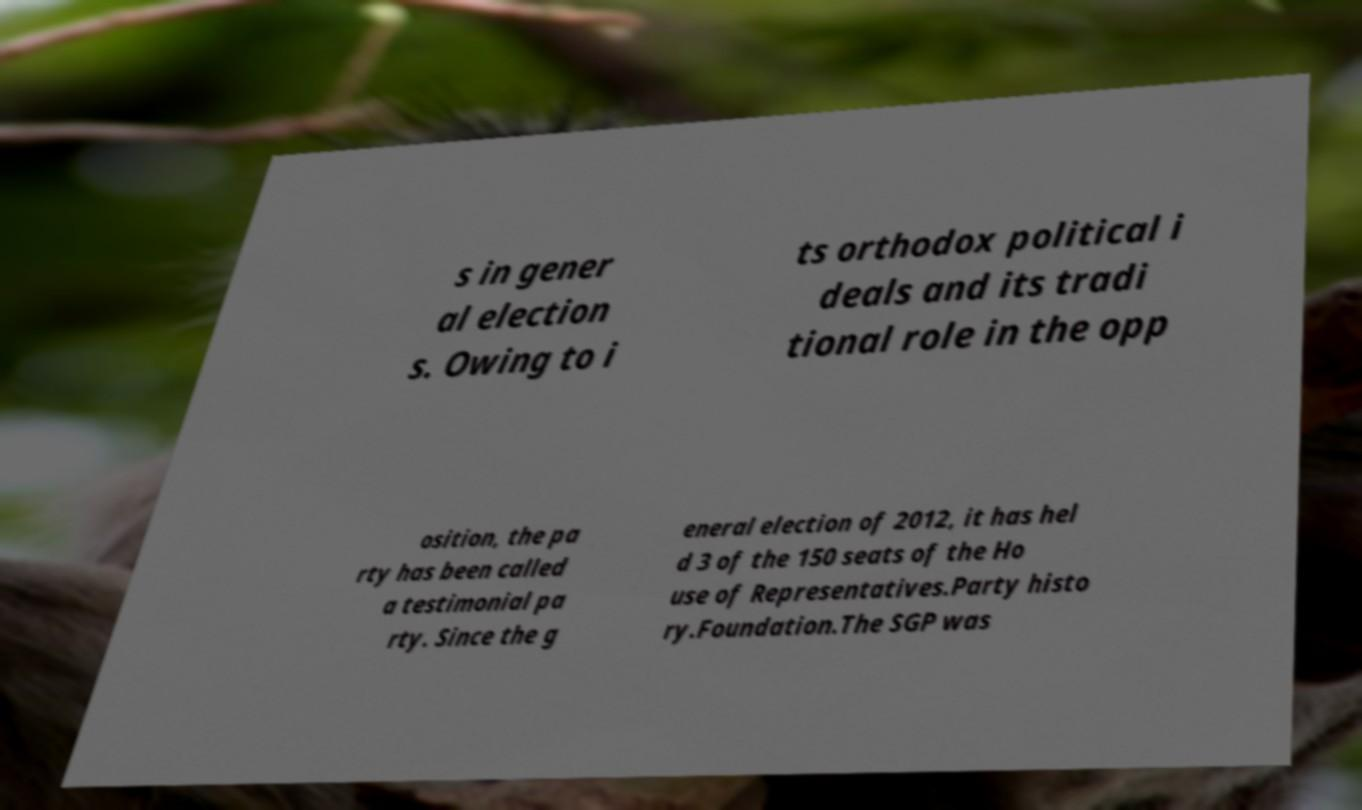Could you extract and type out the text from this image? s in gener al election s. Owing to i ts orthodox political i deals and its tradi tional role in the opp osition, the pa rty has been called a testimonial pa rty. Since the g eneral election of 2012, it has hel d 3 of the 150 seats of the Ho use of Representatives.Party histo ry.Foundation.The SGP was 